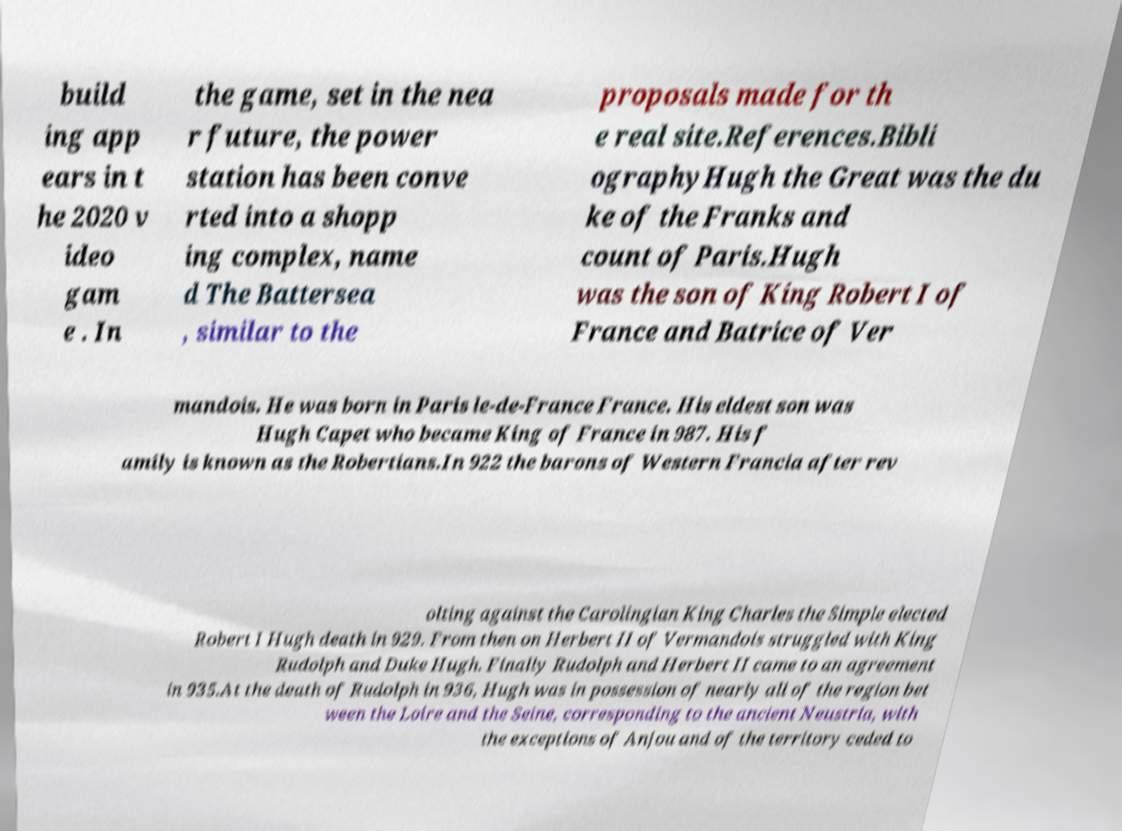I need the written content from this picture converted into text. Can you do that? build ing app ears in t he 2020 v ideo gam e . In the game, set in the nea r future, the power station has been conve rted into a shopp ing complex, name d The Battersea , similar to the proposals made for th e real site.References.Bibli ographyHugh the Great was the du ke of the Franks and count of Paris.Hugh was the son of King Robert I of France and Batrice of Ver mandois. He was born in Paris le-de-France France. His eldest son was Hugh Capet who became King of France in 987. His f amily is known as the Robertians.In 922 the barons of Western Francia after rev olting against the Carolingian King Charles the Simple elected Robert I Hugh death in 929. From then on Herbert II of Vermandois struggled with King Rudolph and Duke Hugh. Finally Rudolph and Herbert II came to an agreement in 935.At the death of Rudolph in 936, Hugh was in possession of nearly all of the region bet ween the Loire and the Seine, corresponding to the ancient Neustria, with the exceptions of Anjou and of the territory ceded to 